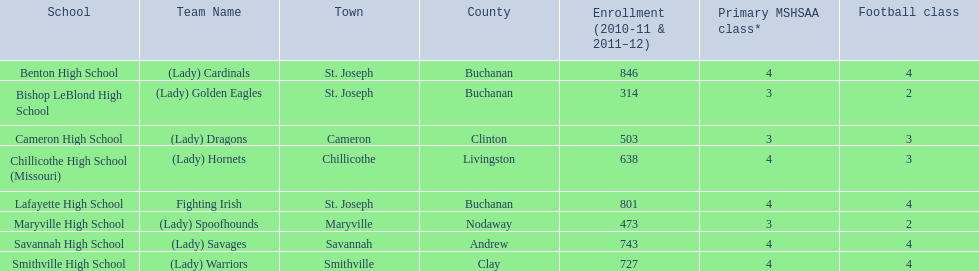Which team has green and grey as their colors? Fighting Irish. What is the name of this team? Lafayette High School. 